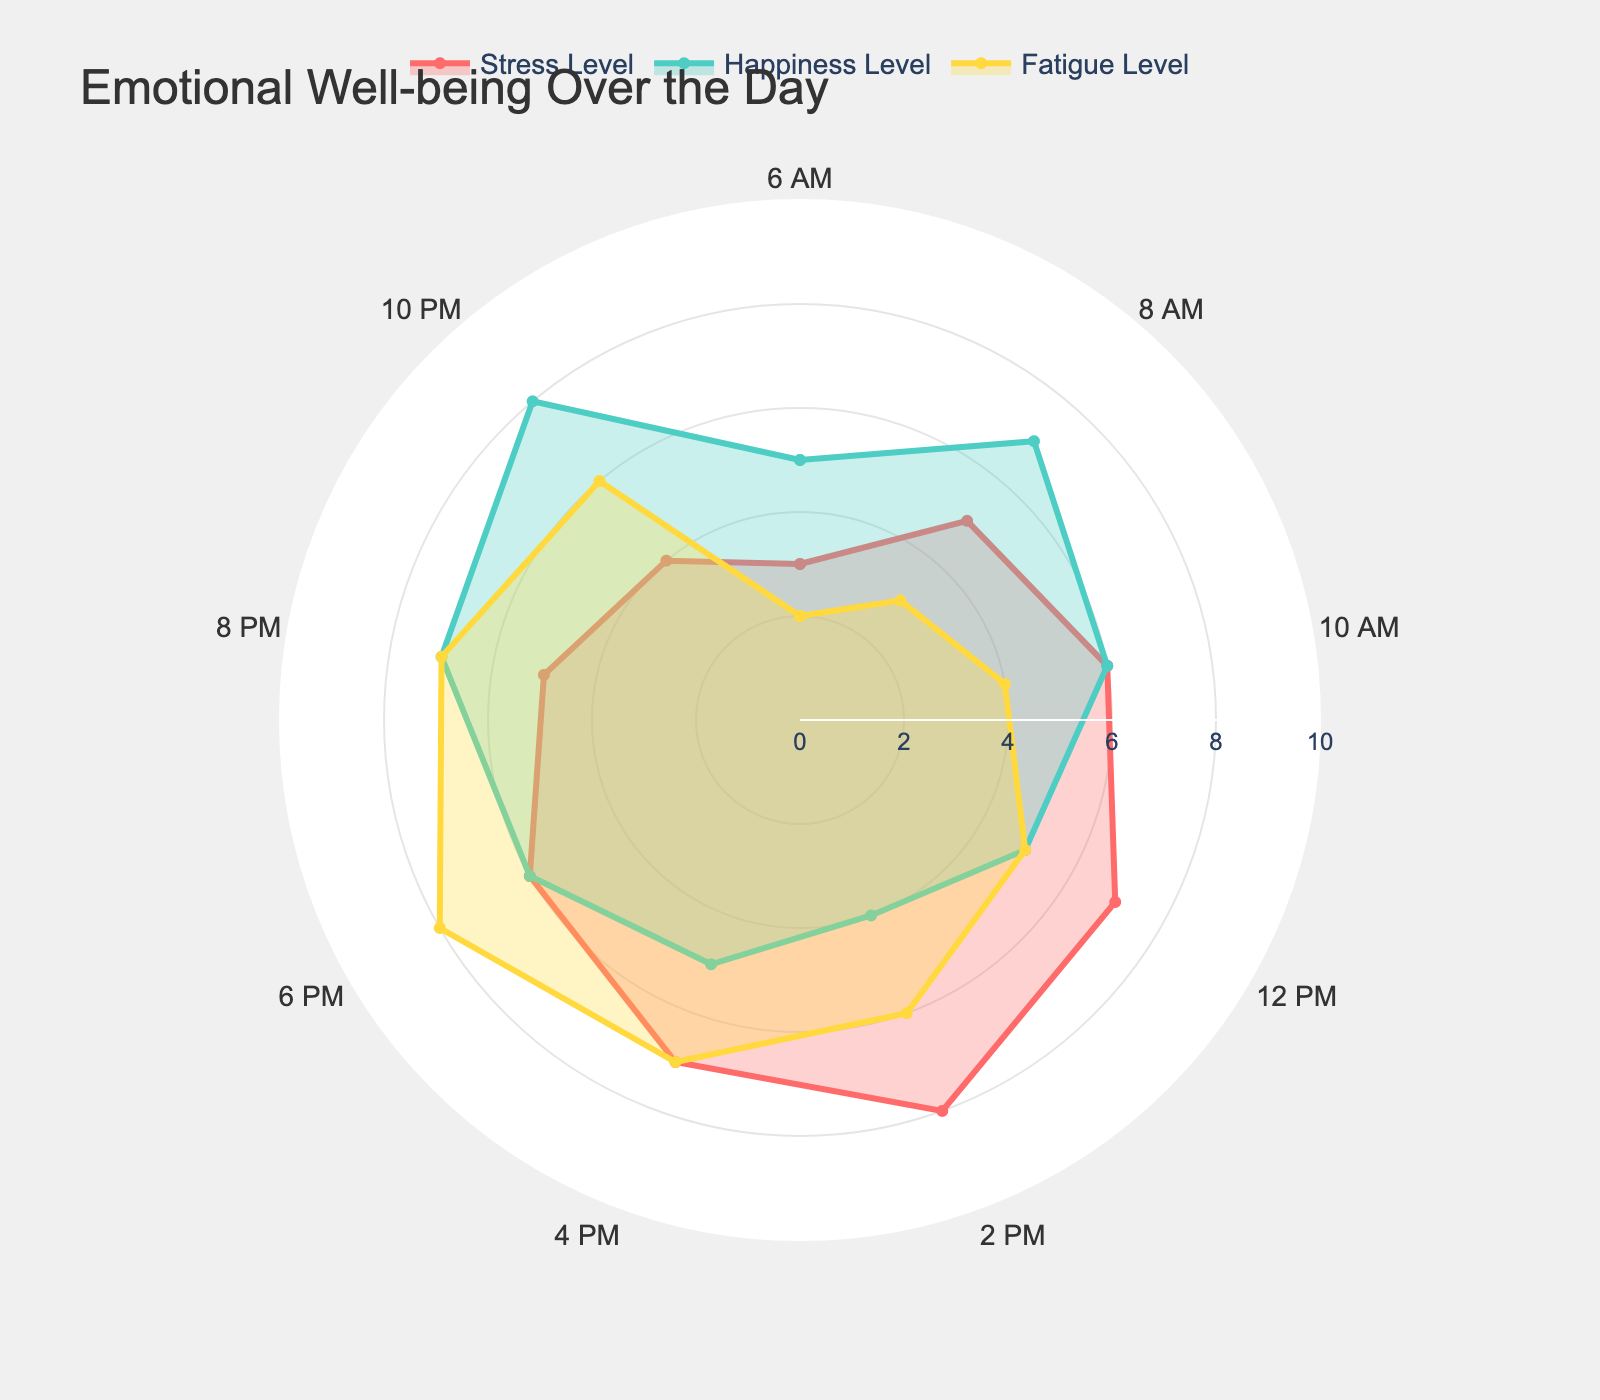What's the title of the figure? The title of the figure is at the top and is written in a larger font size, making it easy to identify.
Answer: Emotional Well-being Over the Day How does the fatigue level change between 6 AM and 8 PM? From 6 AM to 8 PM, the fatigue level gradually increases. At 6 AM, the fatigue level is 2, and it keeps rising to a peak of 8 at 6 PM before slightly dropping to 7 at 8 PM.
Answer: It increases overall Which time of the day has the highest happiness level? By looking at the levels filled with the color representing happiness, we can see that the 10 PM point in the happiness polygon has the highest value, which reaches 8.
Answer: 10 PM Which emotional level is higher at 2 PM, stress or happiness? At 2 PM, we can compare the values represented by the color for stress and the color for happiness. Stress is at 8, while happiness is at 4.
Answer: Stress What is the average stress level across the day? To calculate the average stress level, sum up all the stress values and divide by the number of time points. (3 + 5 + 6 + 7 + 8 + 7 + 6 + 5 + 4) / 9 = 51 / 9 = 5.67
Answer: 5.67 Which time period shows the biggest spike in fatigue level? Looking at the plot, we can see that the fatigue level jumps the most between 4 PM (7) to 6 PM (8).
Answer: Between 4 PM and 6 PM Are there any times of the day when stress and happiness levels are equal? By comparing the stress and happiness segments, we can see there's a point where they touch at 10 AM where both are at level 6.
Answer: 10 AM What general trend can be observed in the stress levels throughout the day? The stress level tends to increase from 6 AM peaking in the afternoon (2 PM), then gradually decreases toward 10 PM.
Answer: Peaks at 2 PM then decreases 